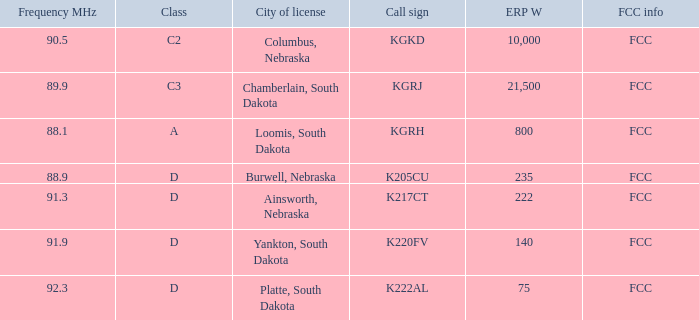What is the total frequency mhz of the kgrj call sign, which has an erp w greater than 21,500? 0.0. 